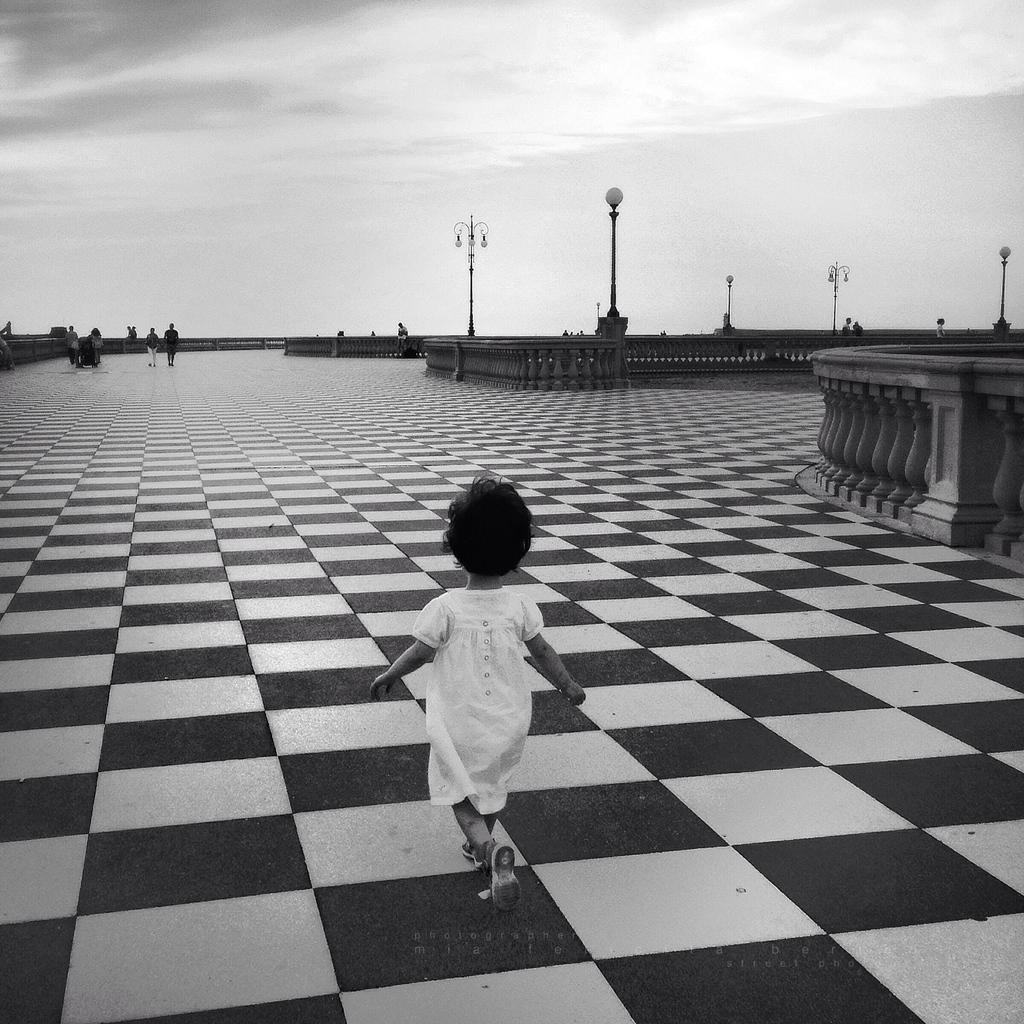Can you describe this image briefly? In this picture there is a girl walking. At the back there are group of people standing and there are light poles and there are railings. At the top are clouds. At the bottom there is a marble floor. 